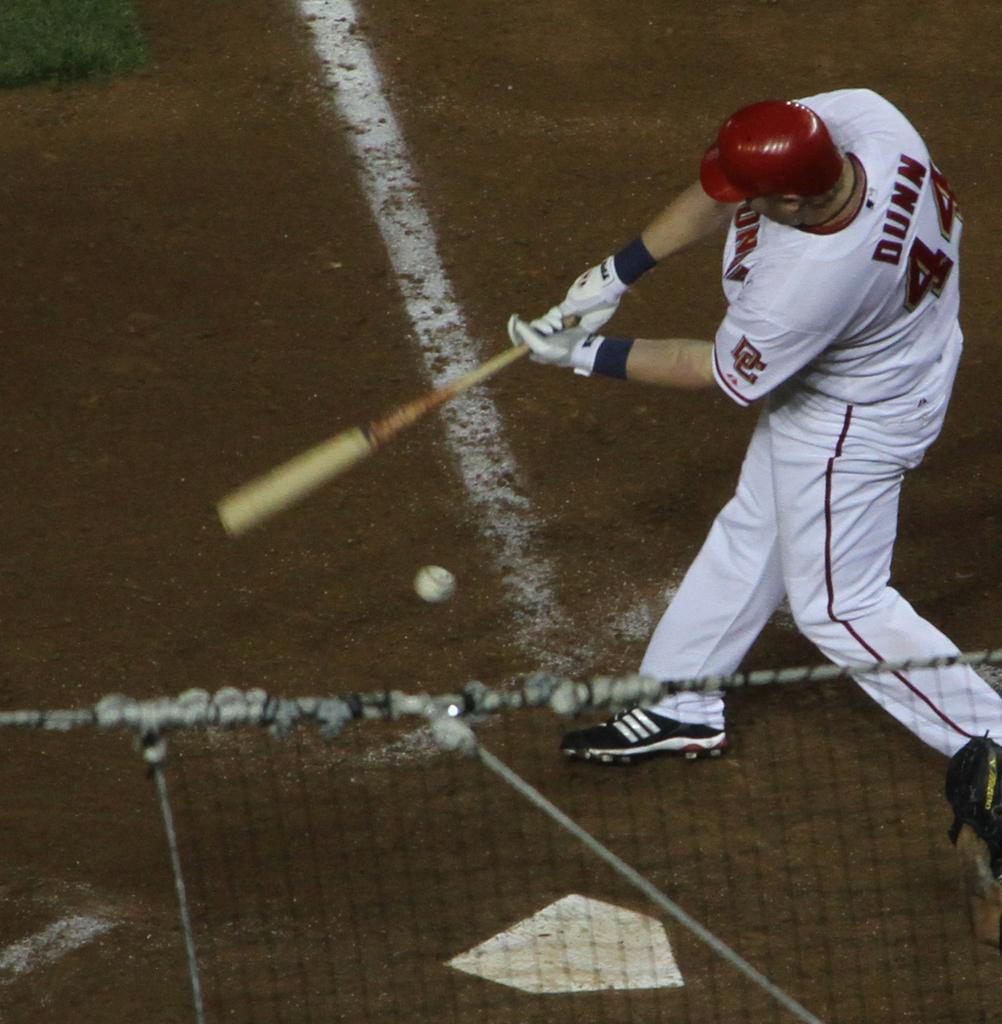<image>
Create a compact narrative representing the image presented. A player called Dunn is swinging at the ball. 